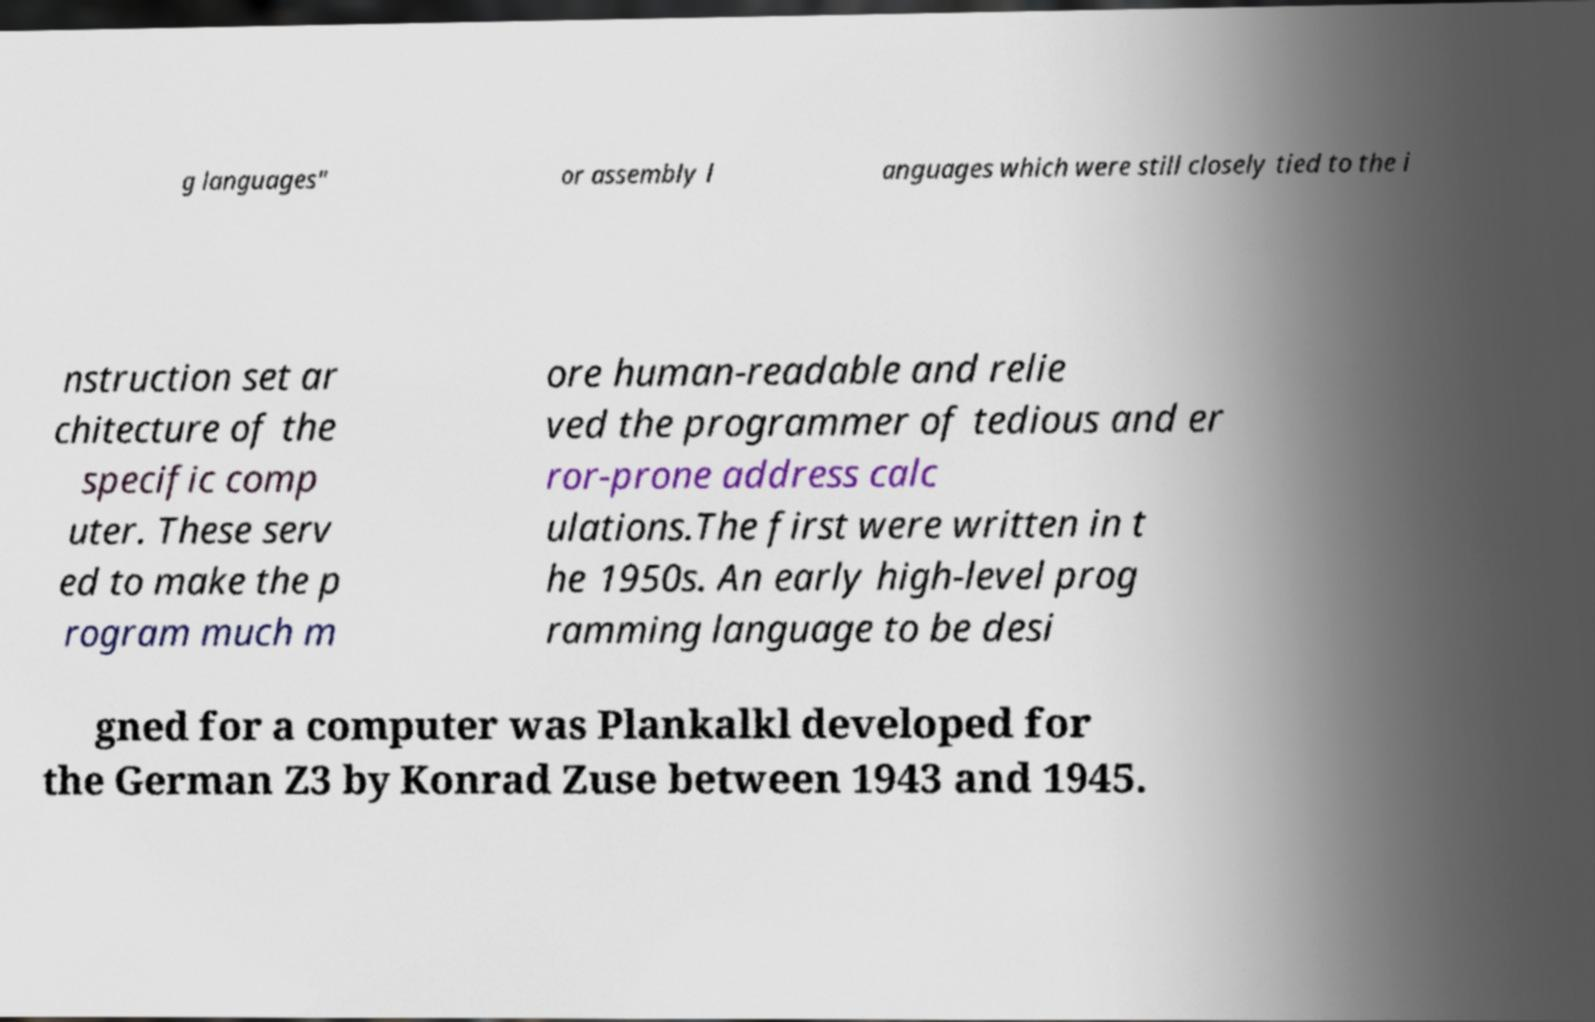For documentation purposes, I need the text within this image transcribed. Could you provide that? g languages" or assembly l anguages which were still closely tied to the i nstruction set ar chitecture of the specific comp uter. These serv ed to make the p rogram much m ore human-readable and relie ved the programmer of tedious and er ror-prone address calc ulations.The first were written in t he 1950s. An early high-level prog ramming language to be desi gned for a computer was Plankalkl developed for the German Z3 by Konrad Zuse between 1943 and 1945. 